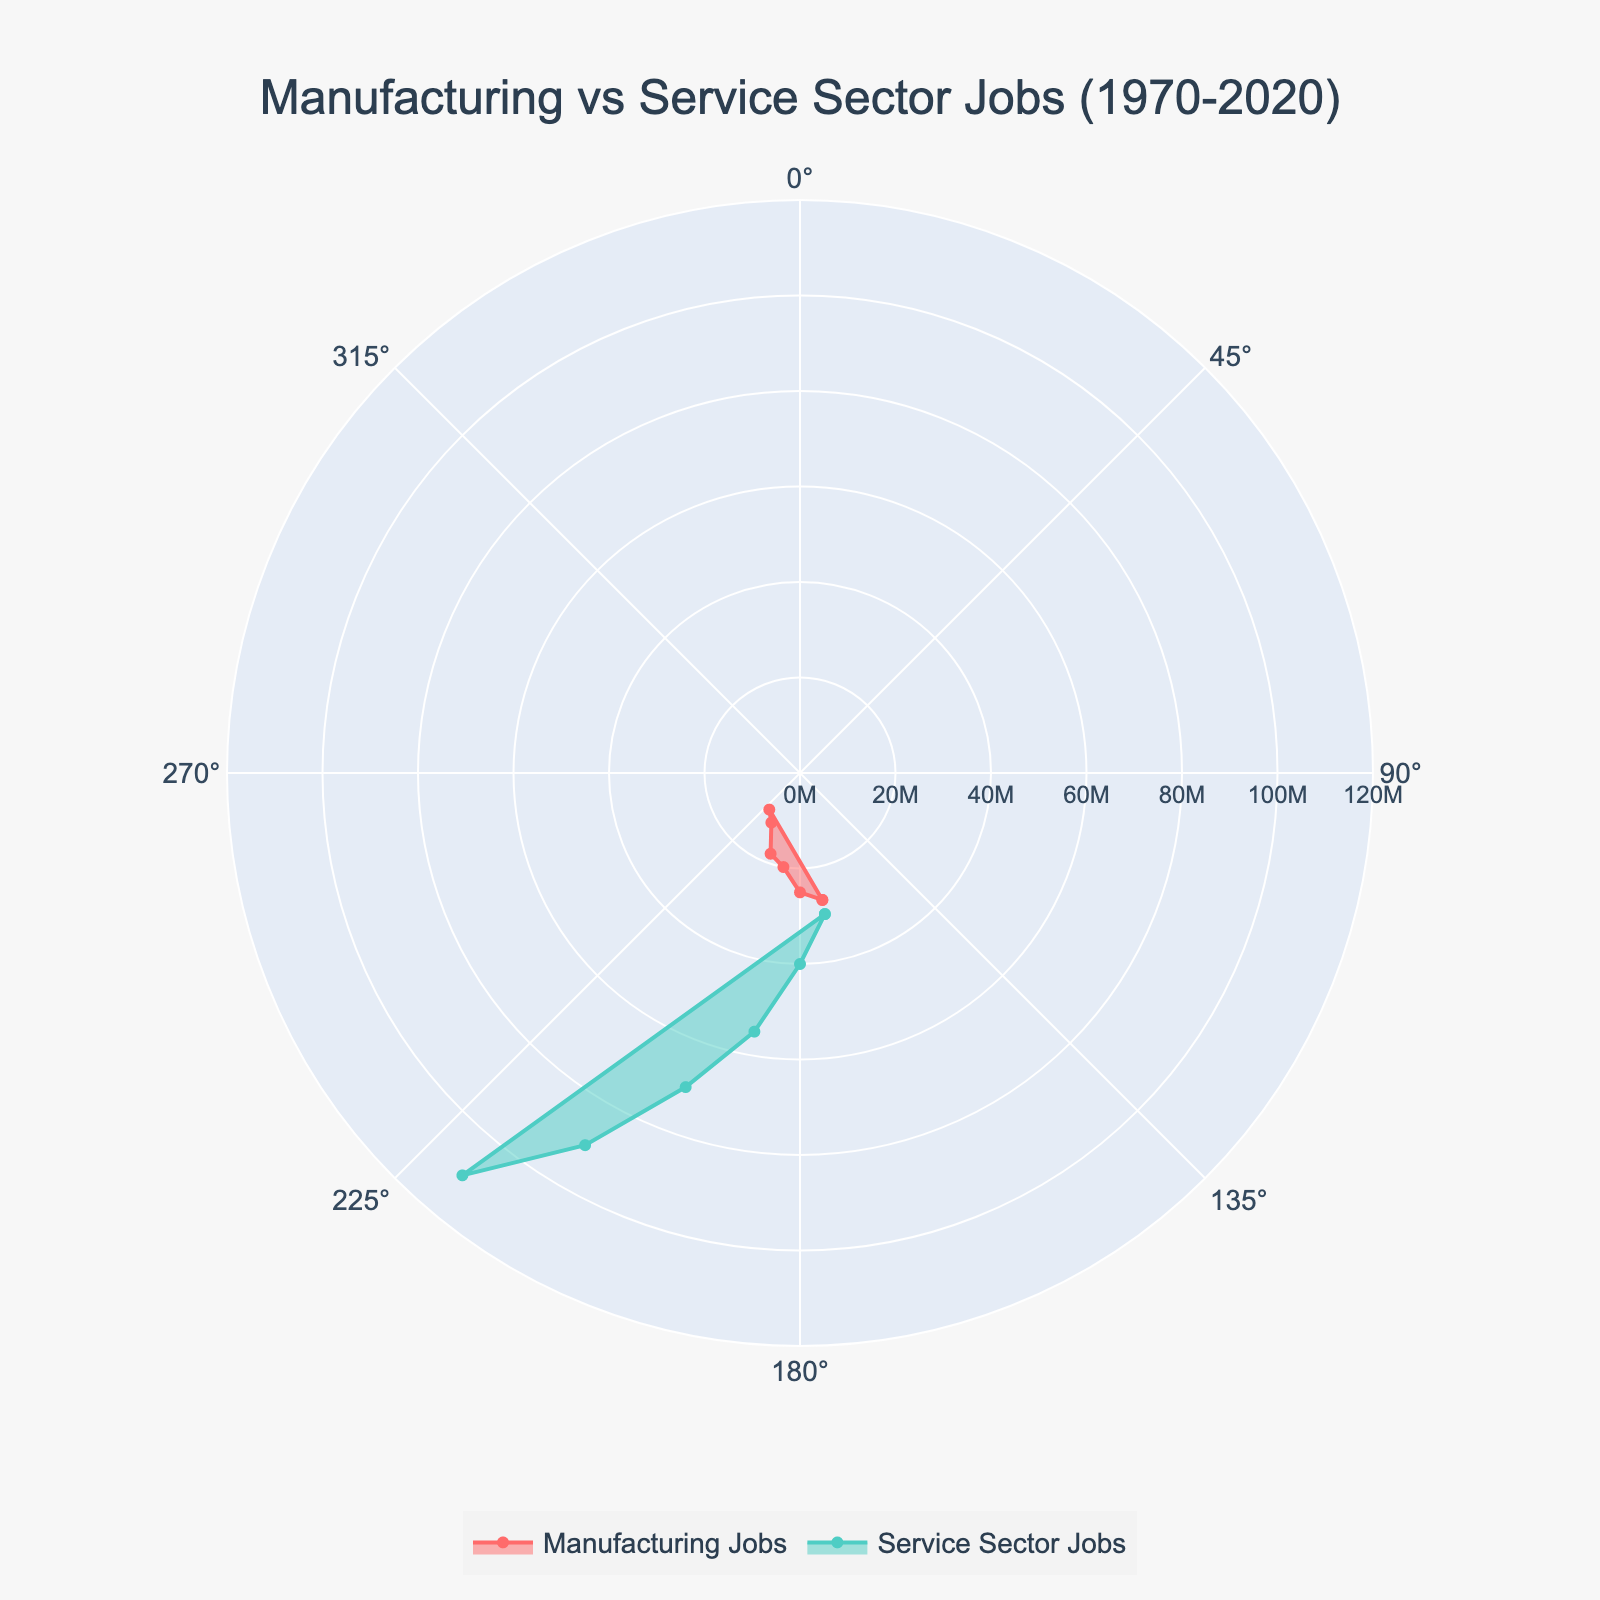What is the title of the chart? The title is usually written at the top of the chart and provides the main subject of the plotted data. Observe the text at the top center of the image.
Answer: Manufacturing vs Service Sector Jobs (1970-2020) How many data points are there for Manufacturing Jobs? Count the number of distinct radial points (r-values) plotted for Manufacturing Jobs, not including the duplicate point for closing the polar plot.
Answer: 6 Between which two consecutive decades did Manufacturing Jobs see the greatest decline? Look at the size of the drop in the radial axis values of Manufacturing Jobs between each consecutive decade.
Answer: 2000-2010 Which year had the highest number of Service Sector Jobs? Identify the year corresponding to the highest value on the radial axis for Service Sector Jobs.
Answer: 2020 In 1990, were there more Manufacturing or Service Sector Jobs? Compare the radial values (r-values) for both Manufacturing and Service Sector Jobs for the year 1990.
Answer: Service Sector Jobs What was the average number of Service Sector Jobs in 1980 and 1990 combined? Add the radial values for Service Sector Jobs in 1980 and 1990, then divide by 2.
Answer: 47.5 Million By how many million did Manufacturing Jobs decrease from 1970 to 2020? Subtract the radial value of Manufacturing Jobs in 2020 from that of 1970.
Answer: 17 Million Which sector has a more significant difference between the starting and ending data points, and what is the value of this difference? Calculate the difference between the first and last radial values for both sectors and compare them.
Answer: Service Sector Jobs; 80 Million What is the average number of Manufacturing Jobs over the entire period from 1970 to 2020? Sum all the radial values for Manufacturing Jobs and divide by the number of data points (6).
Answer: 18.67 Million Is the trend of Manufacturing Jobs increasing, decreasing, or consistent over the years? Observe the general direction of the radial values for Manufacturing Jobs across the decades.
Answer: Decreasing 